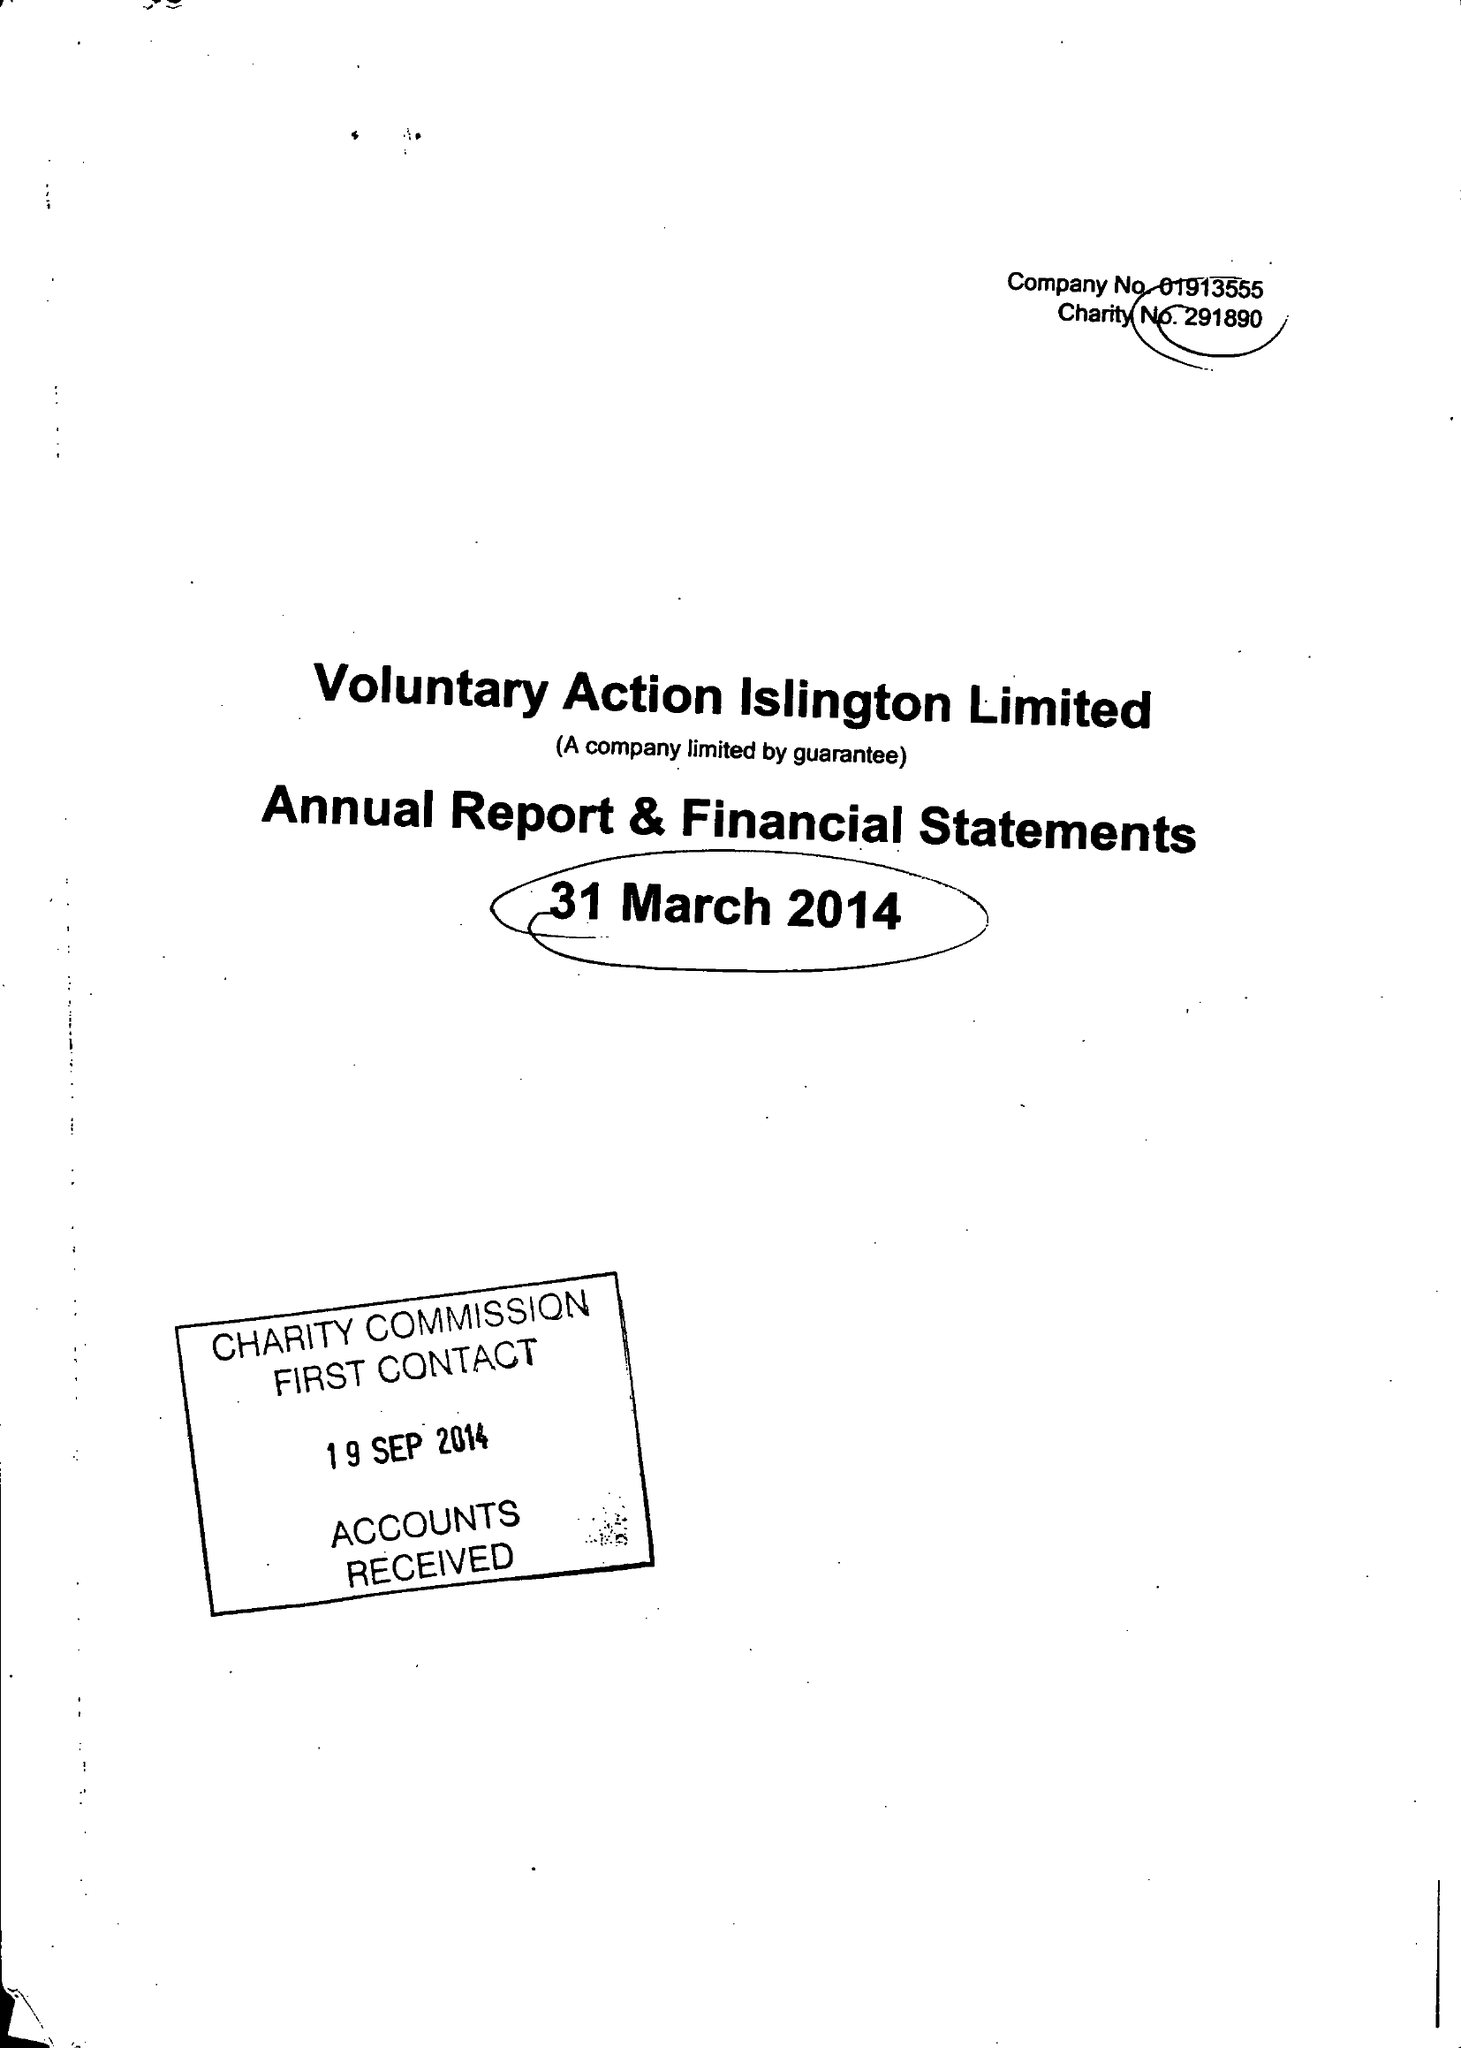What is the value for the report_date?
Answer the question using a single word or phrase. 2014-03-31 